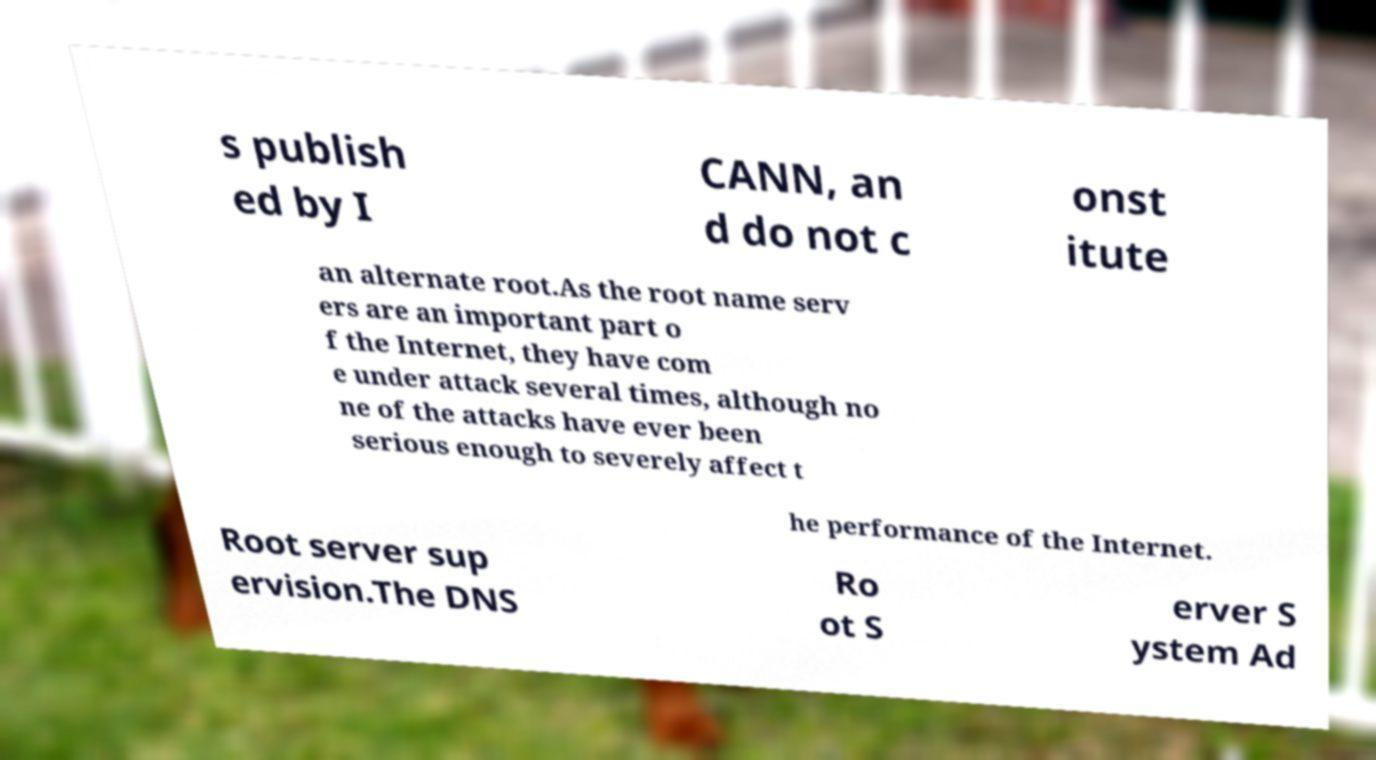Please read and relay the text visible in this image. What does it say? s publish ed by I CANN, an d do not c onst itute an alternate root.As the root name serv ers are an important part o f the Internet, they have com e under attack several times, although no ne of the attacks have ever been serious enough to severely affect t he performance of the Internet. Root server sup ervision.The DNS Ro ot S erver S ystem Ad 